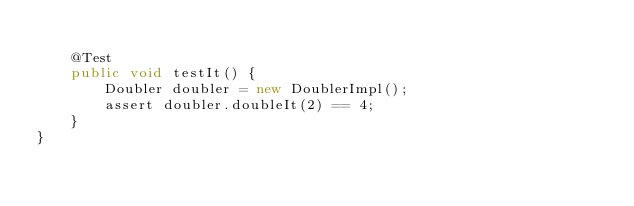<code> <loc_0><loc_0><loc_500><loc_500><_Java_>    
    @Test
    public void testIt() {
        Doubler doubler = new DoublerImpl();
        assert doubler.doubleIt(2) == 4;
    }
}
</code> 